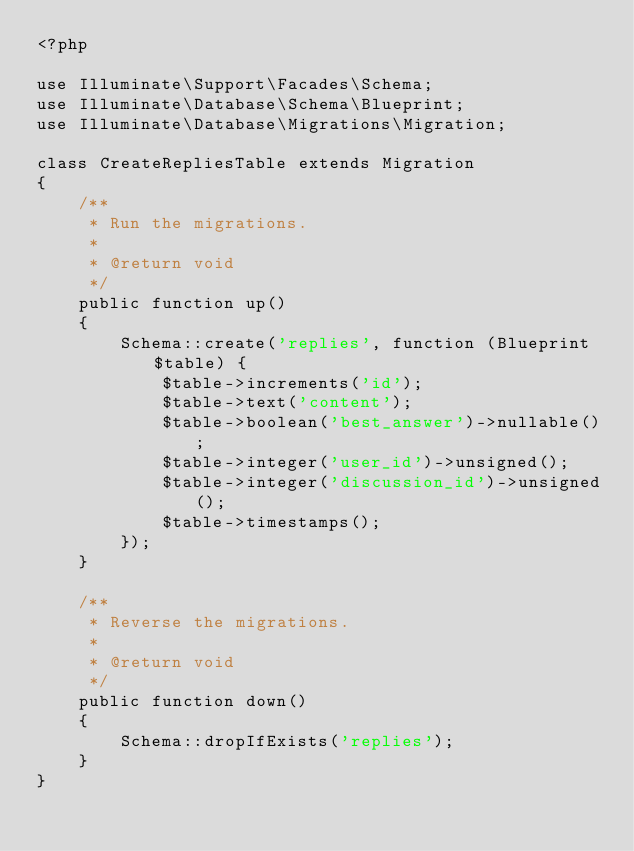<code> <loc_0><loc_0><loc_500><loc_500><_PHP_><?php

use Illuminate\Support\Facades\Schema;
use Illuminate\Database\Schema\Blueprint;
use Illuminate\Database\Migrations\Migration;

class CreateRepliesTable extends Migration
{
    /**
     * Run the migrations.
     *
     * @return void
     */
    public function up()
    {
        Schema::create('replies', function (Blueprint $table) {
            $table->increments('id');
            $table->text('content');
            $table->boolean('best_answer')->nullable();
            $table->integer('user_id')->unsigned();
            $table->integer('discussion_id')->unsigned();
            $table->timestamps();
        });
    }

    /**
     * Reverse the migrations.
     *
     * @return void
     */
    public function down()
    {
        Schema::dropIfExists('replies');
    }
}
</code> 